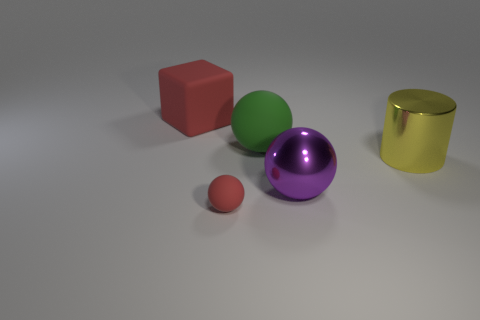Add 1 blocks. How many objects exist? 6 Subtract all balls. How many objects are left? 2 Add 1 green rubber spheres. How many green rubber spheres are left? 2 Add 1 cylinders. How many cylinders exist? 2 Subtract 0 green cubes. How many objects are left? 5 Subtract all tiny red rubber things. Subtract all big green matte objects. How many objects are left? 3 